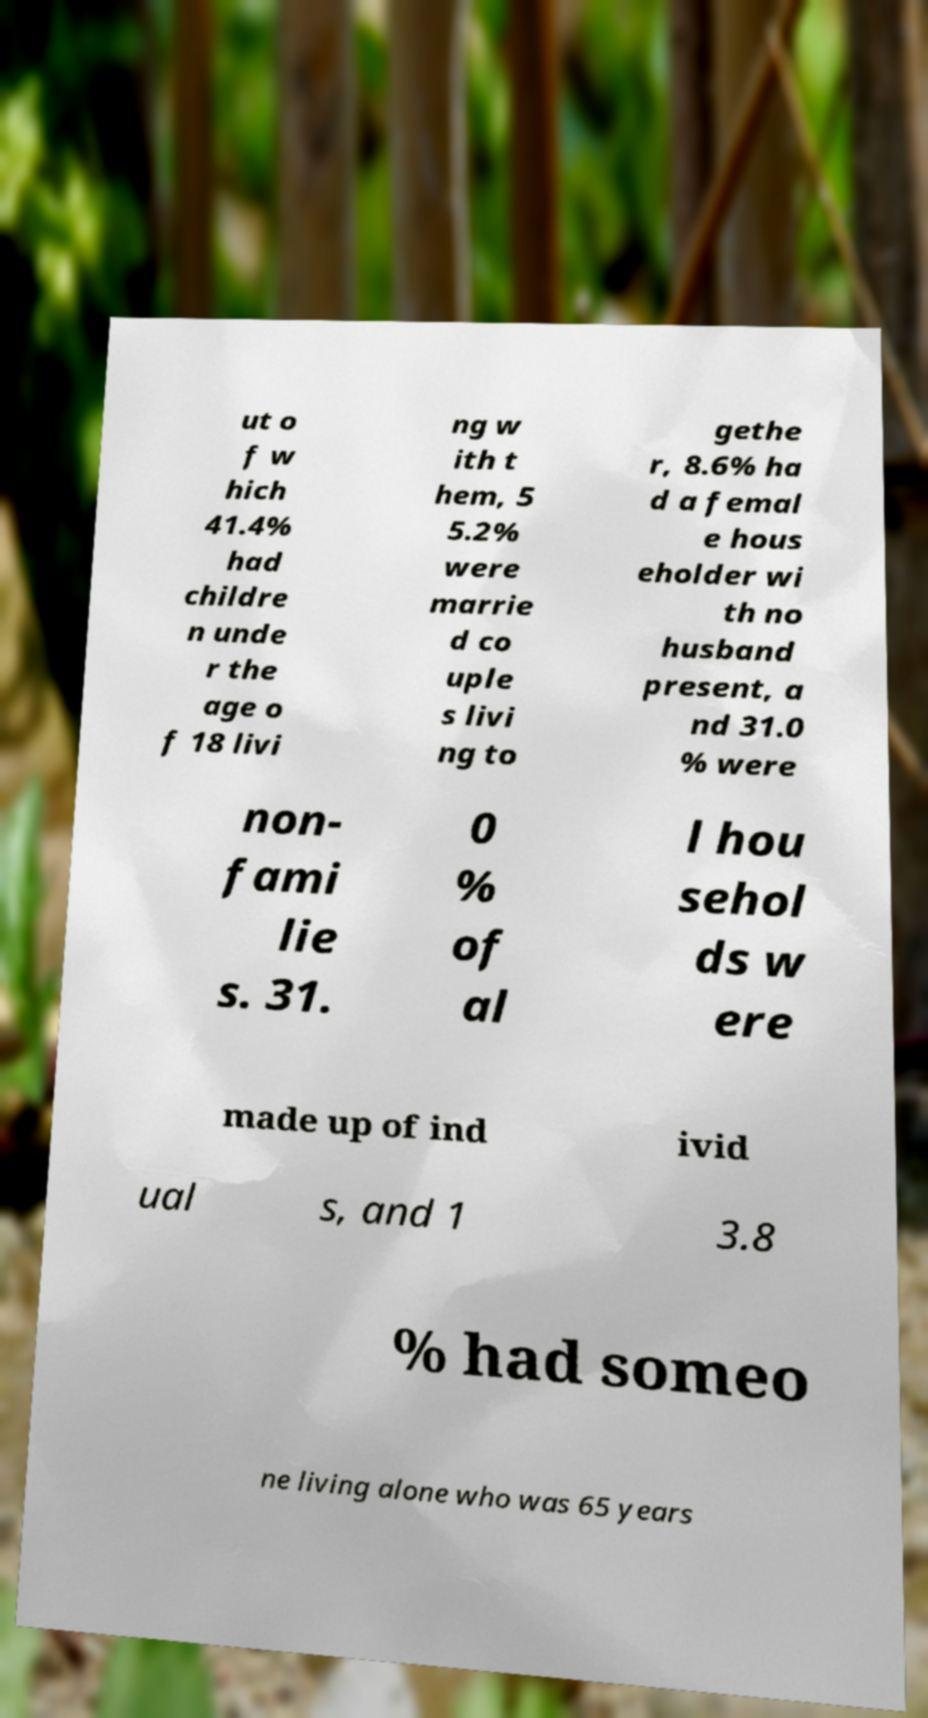Please identify and transcribe the text found in this image. ut o f w hich 41.4% had childre n unde r the age o f 18 livi ng w ith t hem, 5 5.2% were marrie d co uple s livi ng to gethe r, 8.6% ha d a femal e hous eholder wi th no husband present, a nd 31.0 % were non- fami lie s. 31. 0 % of al l hou sehol ds w ere made up of ind ivid ual s, and 1 3.8 % had someo ne living alone who was 65 years 